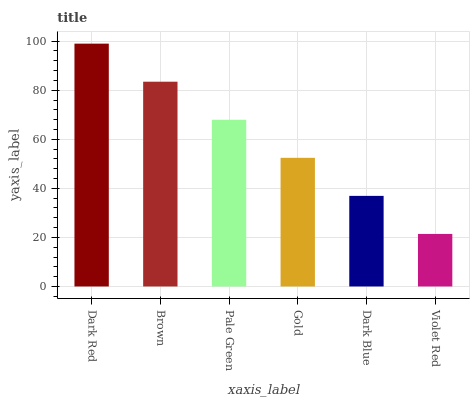Is Brown the minimum?
Answer yes or no. No. Is Brown the maximum?
Answer yes or no. No. Is Dark Red greater than Brown?
Answer yes or no. Yes. Is Brown less than Dark Red?
Answer yes or no. Yes. Is Brown greater than Dark Red?
Answer yes or no. No. Is Dark Red less than Brown?
Answer yes or no. No. Is Pale Green the high median?
Answer yes or no. Yes. Is Gold the low median?
Answer yes or no. Yes. Is Gold the high median?
Answer yes or no. No. Is Pale Green the low median?
Answer yes or no. No. 